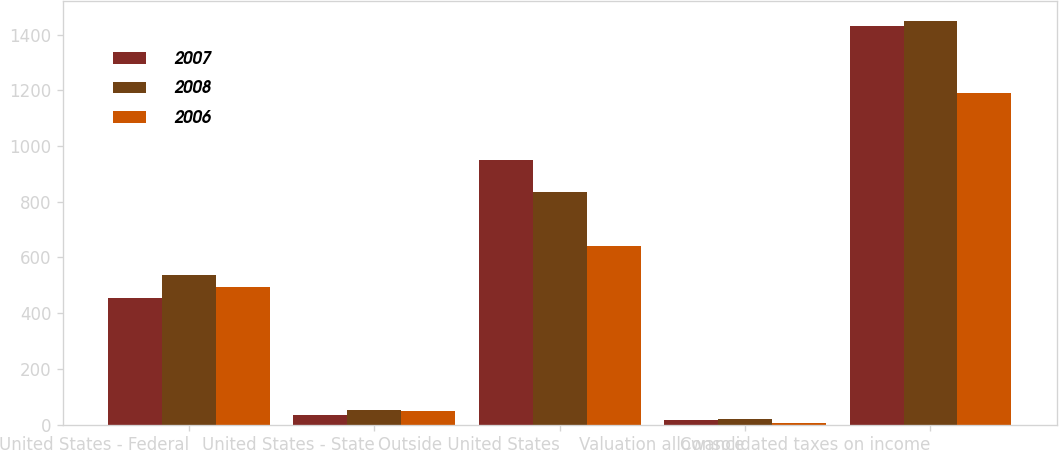Convert chart to OTSL. <chart><loc_0><loc_0><loc_500><loc_500><stacked_bar_chart><ecel><fcel>United States - Federal<fcel>United States - State<fcel>Outside United States<fcel>Valuation allowance<fcel>Consolidated taxes on income<nl><fcel>2007<fcel>453<fcel>34<fcel>949<fcel>18<fcel>1430<nl><fcel>2008<fcel>538<fcel>54<fcel>834<fcel>21<fcel>1448<nl><fcel>2006<fcel>495<fcel>49<fcel>641<fcel>5<fcel>1190<nl></chart> 